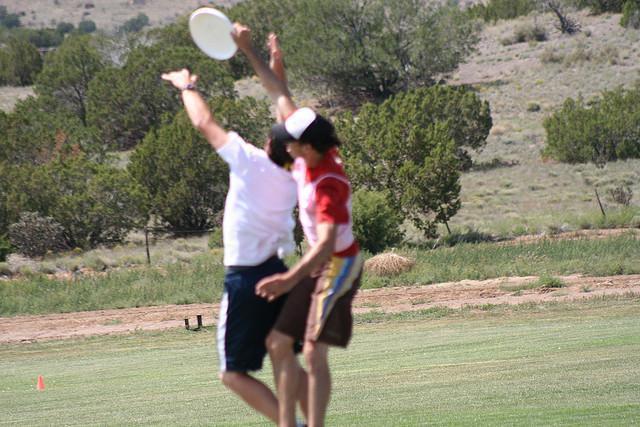How many people can be seen?
Give a very brief answer. 2. 